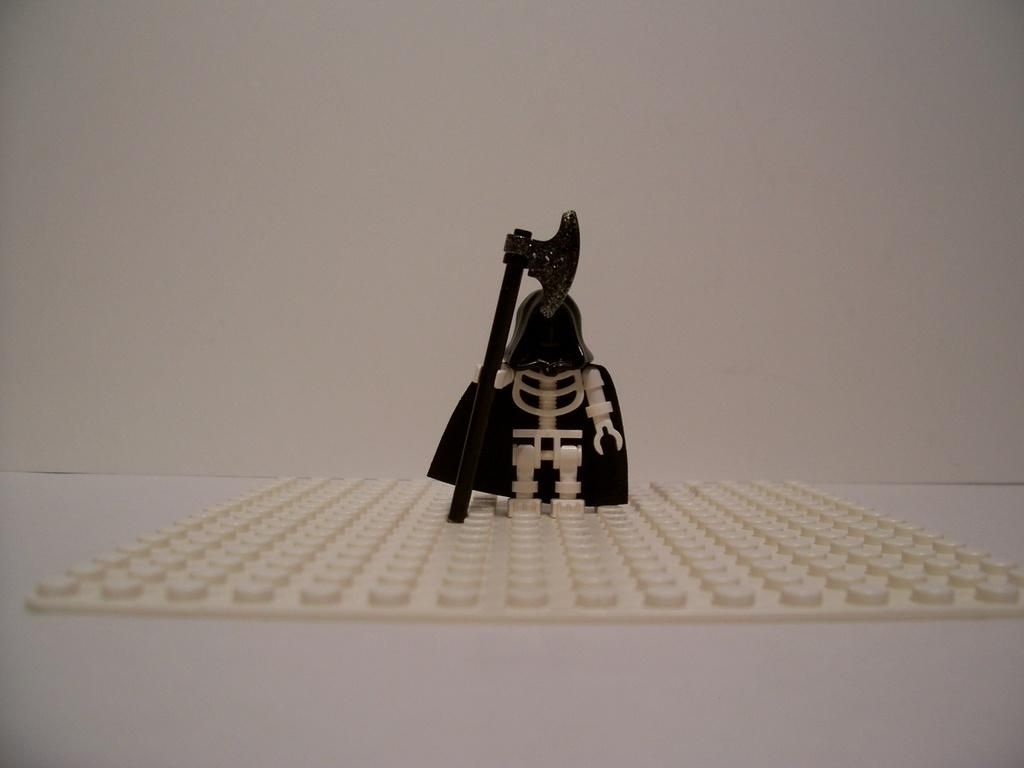What is the main object in the image? There is a toy in the image. What colors can be seen on the toy? The toy is cream and black in color. What is the toy placed on? The toy is on a cream-colored sheet. What color is the surface beneath the sheet? The toy is on a white-colored surface. What color is the background of the image? The background of the image is white. Reasoning: Let'g: Let's think step by step in order to produce the conversation. We start by identifying the main object in the image, which is the toy. Then, we describe the colors of the toy and its placement on the sheet and surface. Finally, we mention the background color of the image. Each question is designed to elicit a specific detail about the image that is known from the provided facts. Absurd Question/Answer: What type of plot is being discussed in the image? There is no plot or discussion present in the image; it is a still image of a toy on a sheet. What kind of plants can be seen growing in the image? There are no plants visible in the image; it features a toy on a sheet with a white background. What type of shirt is the toy wearing in the image? The toy is not a living being and therefore cannot wear a shirt. The toy is a cream and black object in the image. 